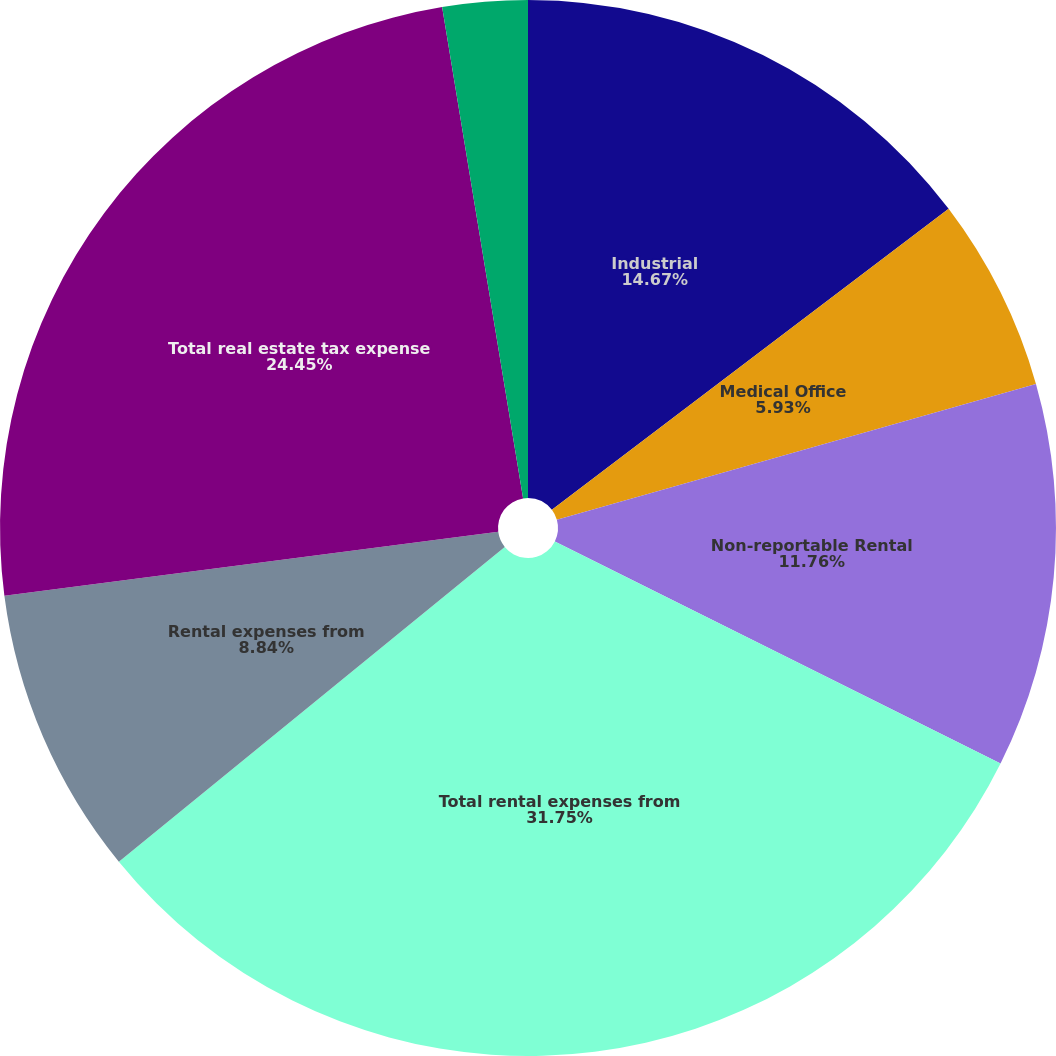<chart> <loc_0><loc_0><loc_500><loc_500><pie_chart><fcel>Industrial<fcel>Medical Office<fcel>Non-reportable Rental<fcel>Total rental expenses from<fcel>Rental expenses from<fcel>Total real estate tax expense<fcel>Real estate tax expense from<nl><fcel>14.67%<fcel>5.93%<fcel>11.76%<fcel>31.75%<fcel>8.84%<fcel>24.45%<fcel>2.6%<nl></chart> 